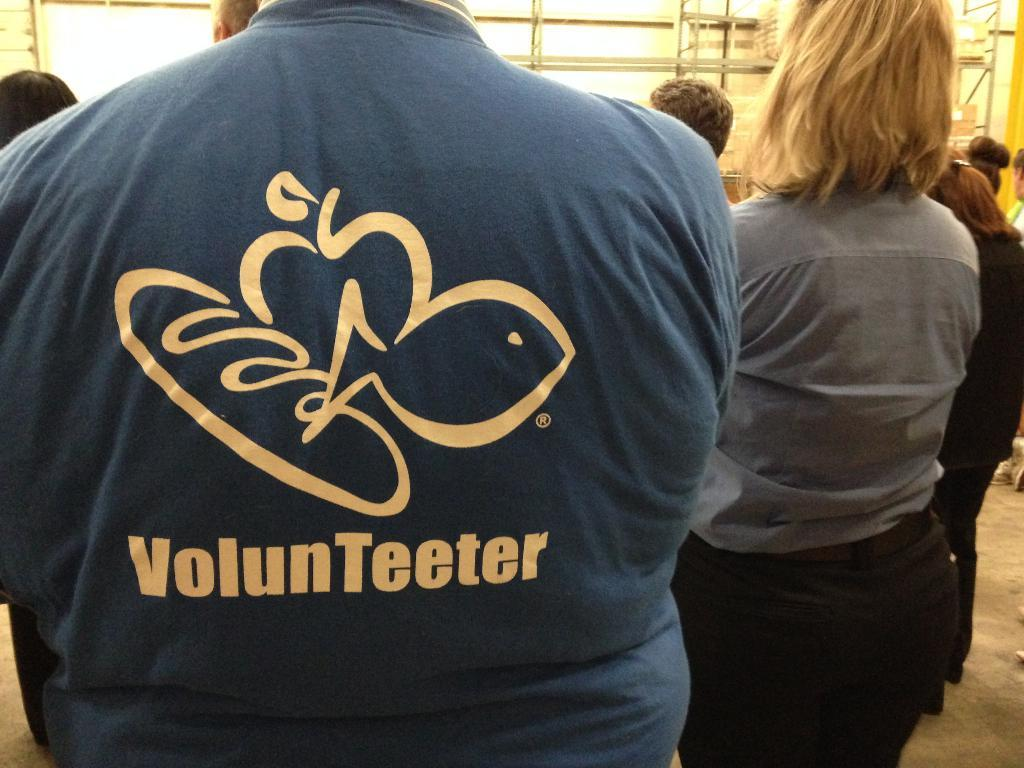<image>
Present a compact description of the photo's key features. A man has the word VolunTeeter  in yellow on the back of his top. 